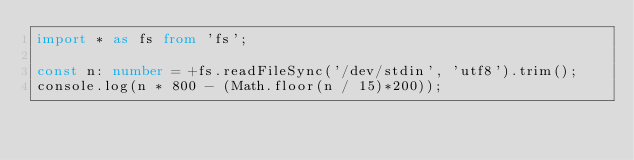Convert code to text. <code><loc_0><loc_0><loc_500><loc_500><_TypeScript_>import * as fs from 'fs';

const n: number = +fs.readFileSync('/dev/stdin', 'utf8').trim();
console.log(n * 800 - (Math.floor(n / 15)*200));
</code> 